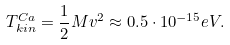<formula> <loc_0><loc_0><loc_500><loc_500>T ^ { C a } _ { k i n } = \frac { 1 } { 2 } M v ^ { 2 } \approx 0 . 5 \cdot 1 0 ^ { - 1 5 } e V .</formula> 